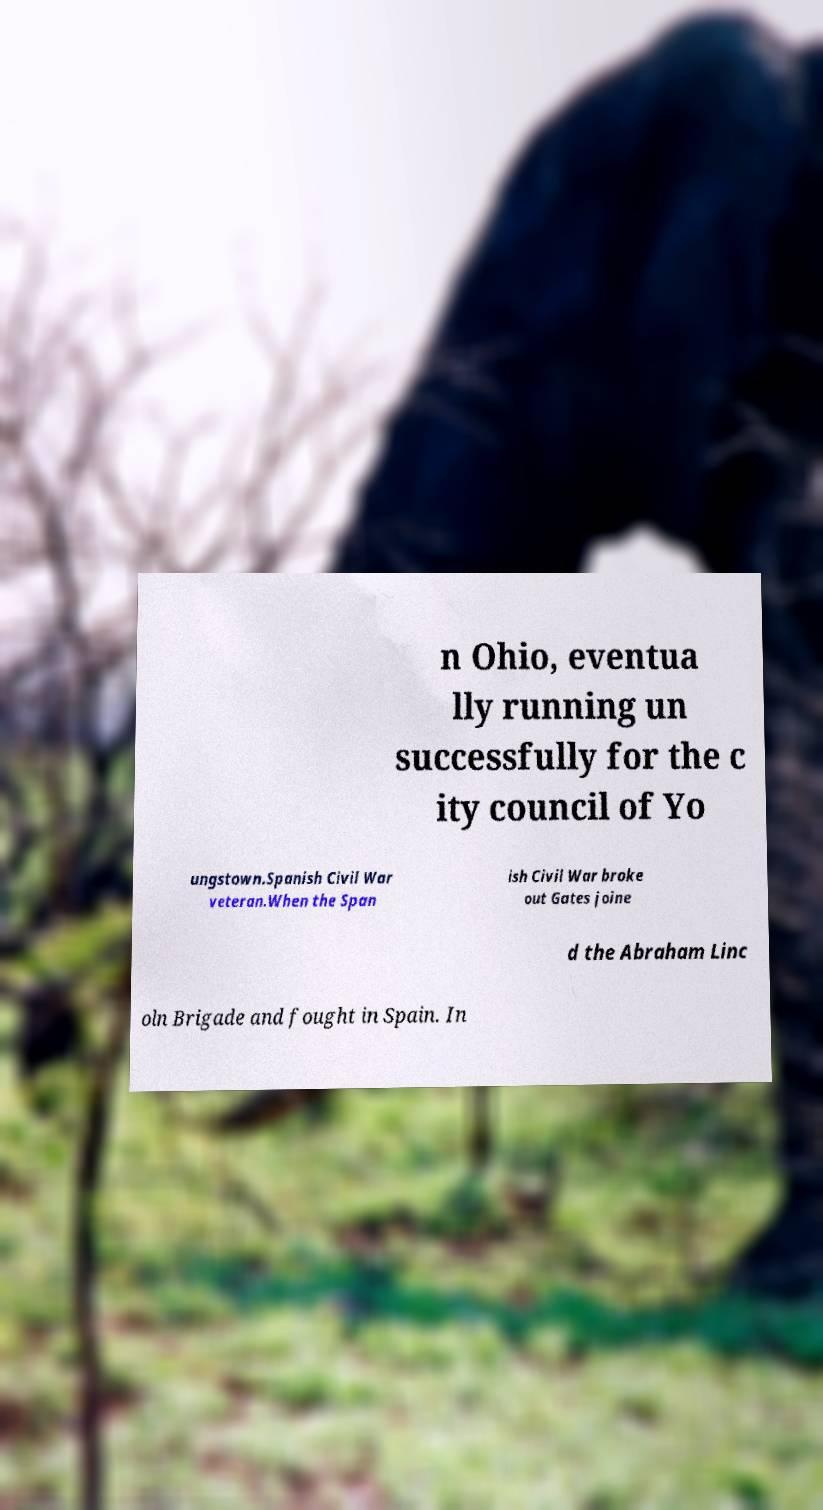For documentation purposes, I need the text within this image transcribed. Could you provide that? n Ohio, eventua lly running un successfully for the c ity council of Yo ungstown.Spanish Civil War veteran.When the Span ish Civil War broke out Gates joine d the Abraham Linc oln Brigade and fought in Spain. In 